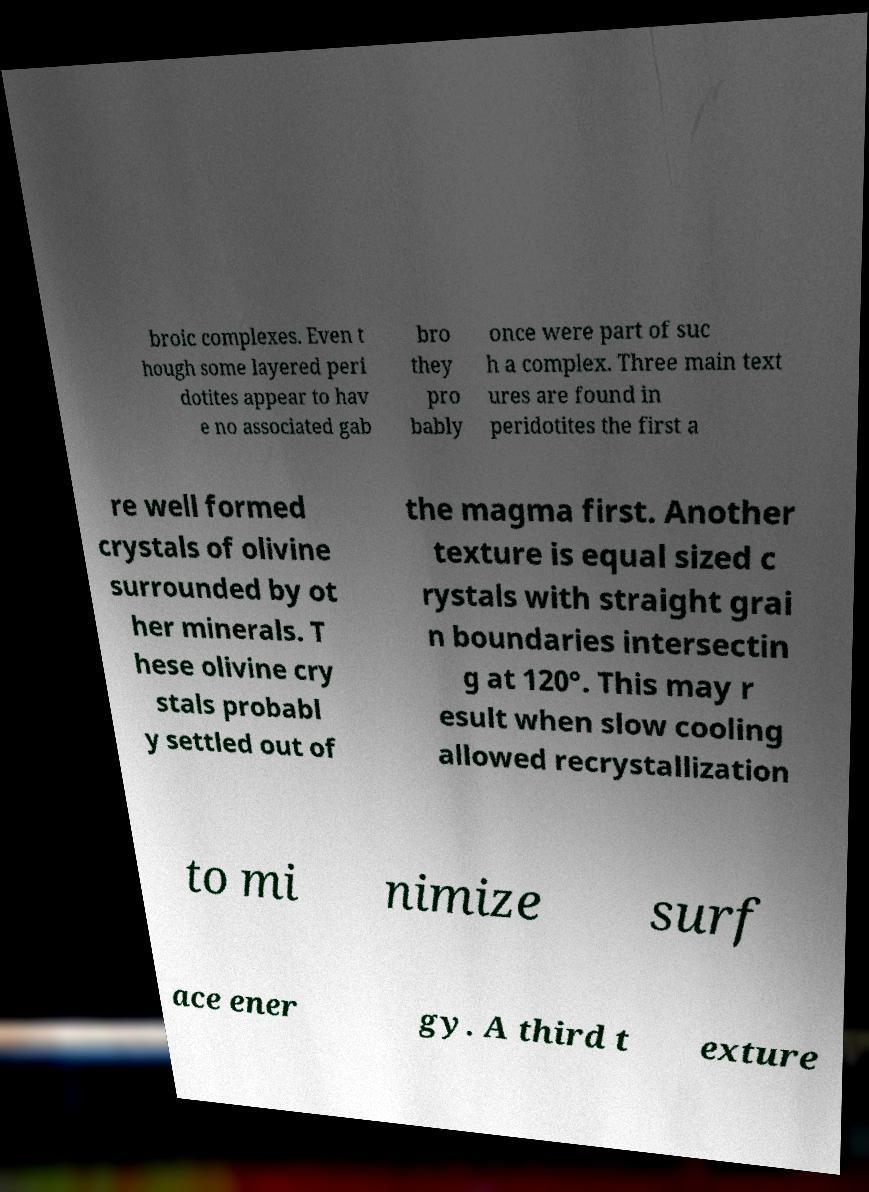What messages or text are displayed in this image? I need them in a readable, typed format. broic complexes. Even t hough some layered peri dotites appear to hav e no associated gab bro they pro bably once were part of suc h a complex. Three main text ures are found in peridotites the first a re well formed crystals of olivine surrounded by ot her minerals. T hese olivine cry stals probabl y settled out of the magma first. Another texture is equal sized c rystals with straight grai n boundaries intersectin g at 120°. This may r esult when slow cooling allowed recrystallization to mi nimize surf ace ener gy. A third t exture 